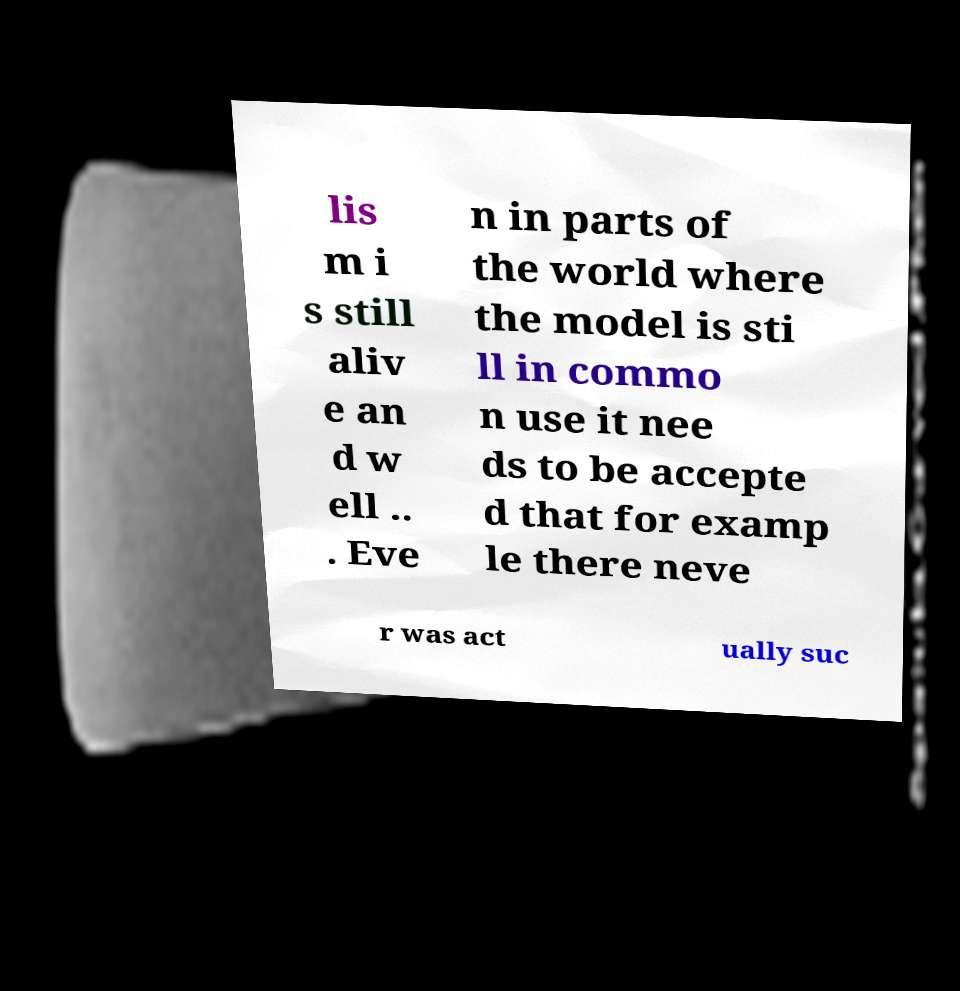Please read and relay the text visible in this image. What does it say? lis m i s still aliv e an d w ell .. . Eve n in parts of the world where the model is sti ll in commo n use it nee ds to be accepte d that for examp le there neve r was act ually suc 